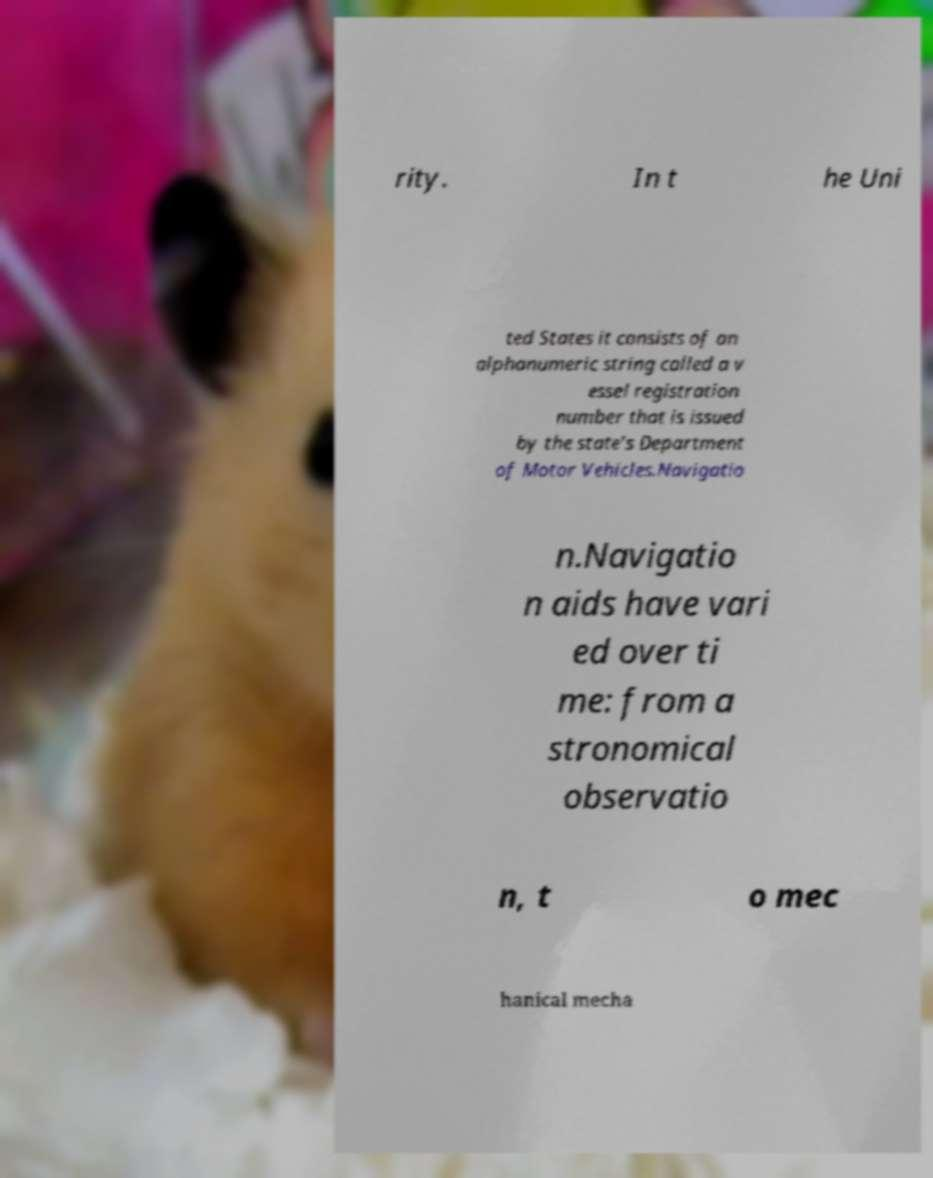Please read and relay the text visible in this image. What does it say? rity. In t he Uni ted States it consists of an alphanumeric string called a v essel registration number that is issued by the state's Department of Motor Vehicles.Navigatio n.Navigatio n aids have vari ed over ti me: from a stronomical observatio n, t o mec hanical mecha 